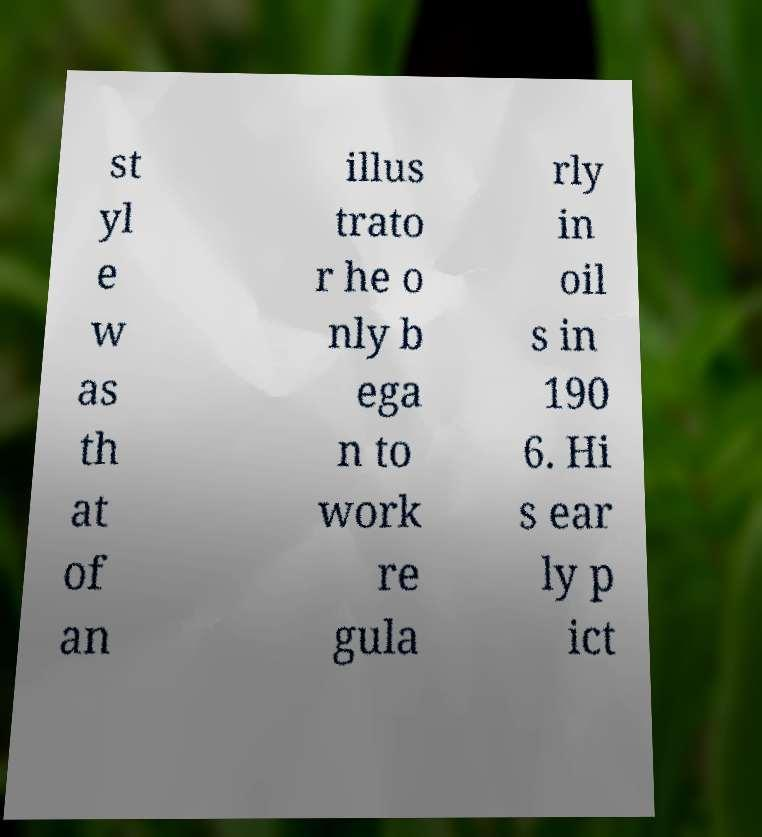What messages or text are displayed in this image? I need them in a readable, typed format. st yl e w as th at of an illus trato r he o nly b ega n to work re gula rly in oil s in 190 6. Hi s ear ly p ict 